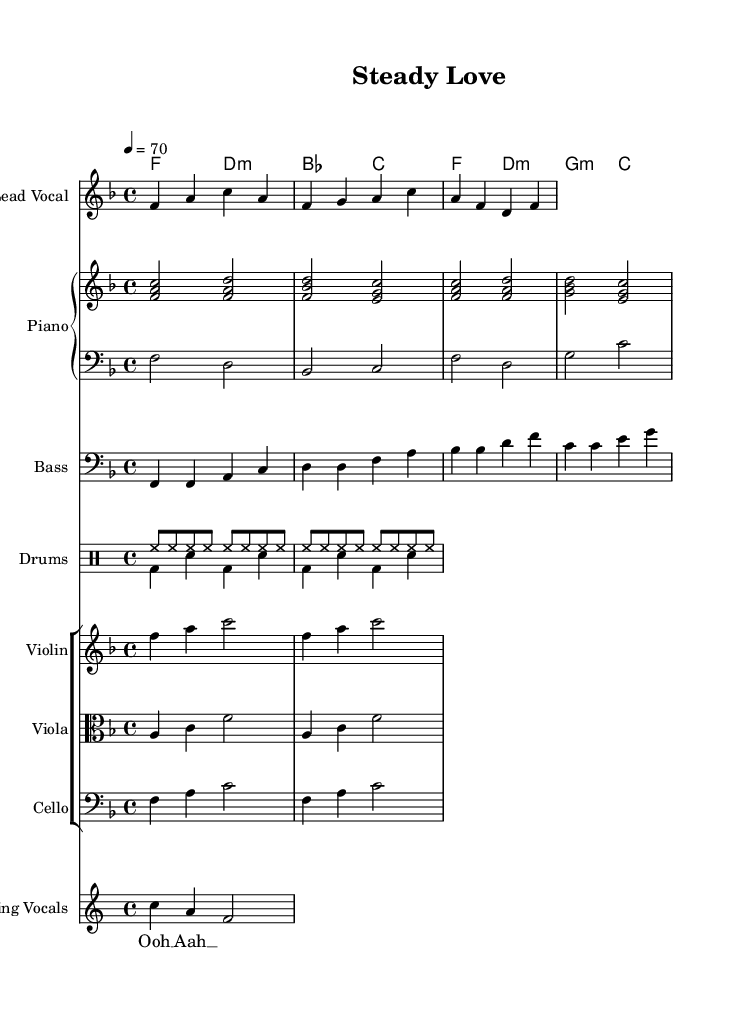What is the key signature of this music? The key signature indicated at the beginning of the sheet music is F major, which has one flat (B flat).
Answer: F major What is the time signature of this music? The time signature shown at the start of the sheet music is 4/4, indicating four beats per measure.
Answer: 4/4 What is the tempo marking of this piece? The tempo marking indicates that the piece should be played at a speed of 70 beats per minute, as shown in the tempo indication.
Answer: 70 How many measures are in the melody section? By counting the distinct grouping of notes (measures) in the melody section, we find there are four measures in total.
Answer: 4 What is the chord progression in the first half of the piece? The chord progression in the first half shown in the chordNames is F major, D minor, B flat major, and C major (F, d:m, bes, c).
Answer: F, d:m, bes, c What instruments are included in this arrangement? The arrangement includes Lead Vocal, Piano (with RH and LH), Bass, Drums, Violin, Viola, Cello, and Backing Vocals.
Answer: Lead Vocal, Piano, Bass, Drums, Violin, Viola, Cello, Backing Vocals What characteristic harmony style is used in this Soul ballad? The harmony style incorporates carefully crafted harmonies that emphasize smooth transitions between chords, reflecting the genre's emotional depth.
Answer: Carefully crafted harmonies 